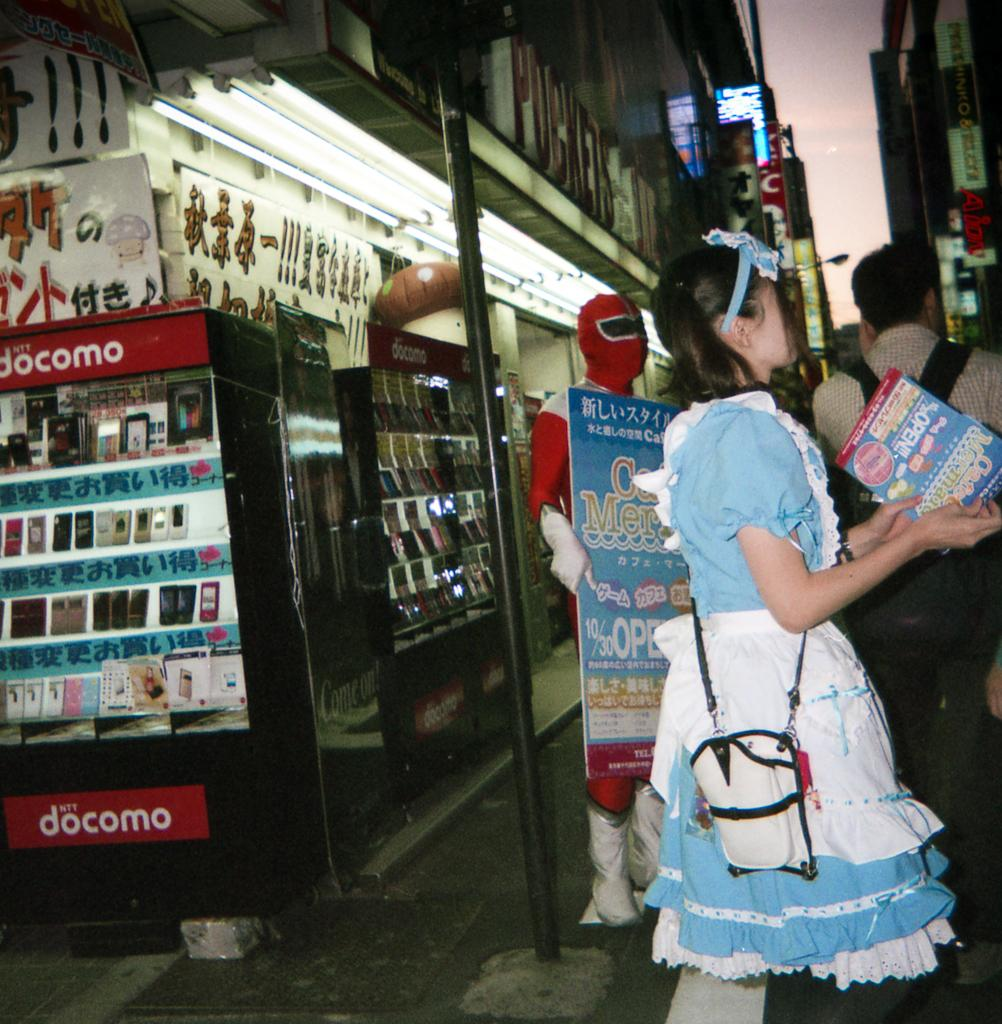<image>
Present a compact description of the photo's key features. A lady outside a store with a fridge called docomo. 